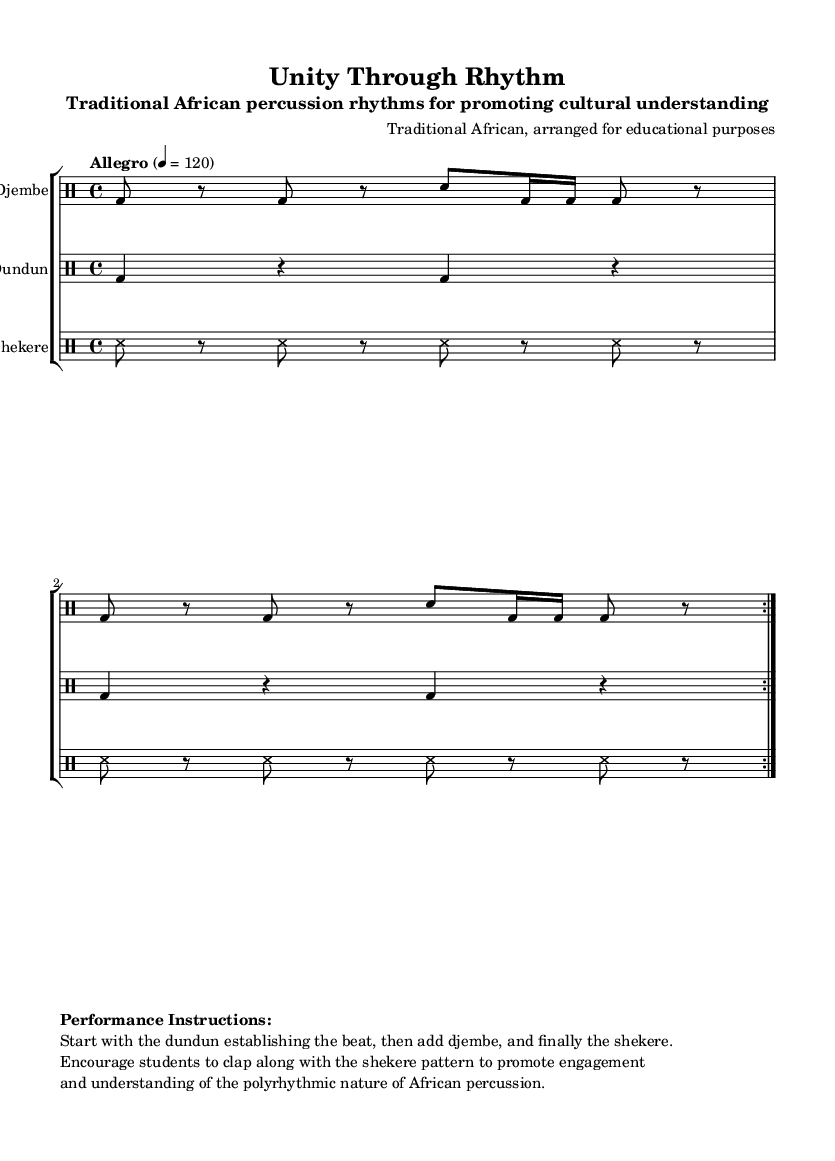What is the key signature of this music? The key signature shown in the music is C major, as there are no sharps or flats indicated in the signature.
Answer: C major What is the time signature of this music? The time signature indicated in the sheet music is 4/4, meaning there are four beats in each measure.
Answer: 4/4 What is the tempo marking indicated for this piece? The tempo marking in the music states "Allegro" with a tempo of 120 beats per minute, indicating a fast pace.
Answer: Allegro, 120 How many times is the djembe rhythm repeated? The djembe rhythm has a repeat instruction "volta 2" indicating that it should be played twice.
Answer: 2 Which percussion instrument lays down the foundational beat? The dundun is the percussion instrument that establishes the beat at the start of the performance.
Answer: Dundun What is the performance instruction about student engagement? The performance instructions encourage students to clap along with the shekere pattern to promote engagement, highlighting the interactive element of learning rhythms.
Answer: Clap along with the shekere pattern How does the arrangement of rhythms reflect African polyrhythmic traditions? The arrangement combines three different percussion instruments (djembe, dundun, and shekere) each playing different rhythmic patterns simultaneously, typical of African music which often features multiple interlocking rhythms.
Answer: Different rhythmic patterns simultaneously 